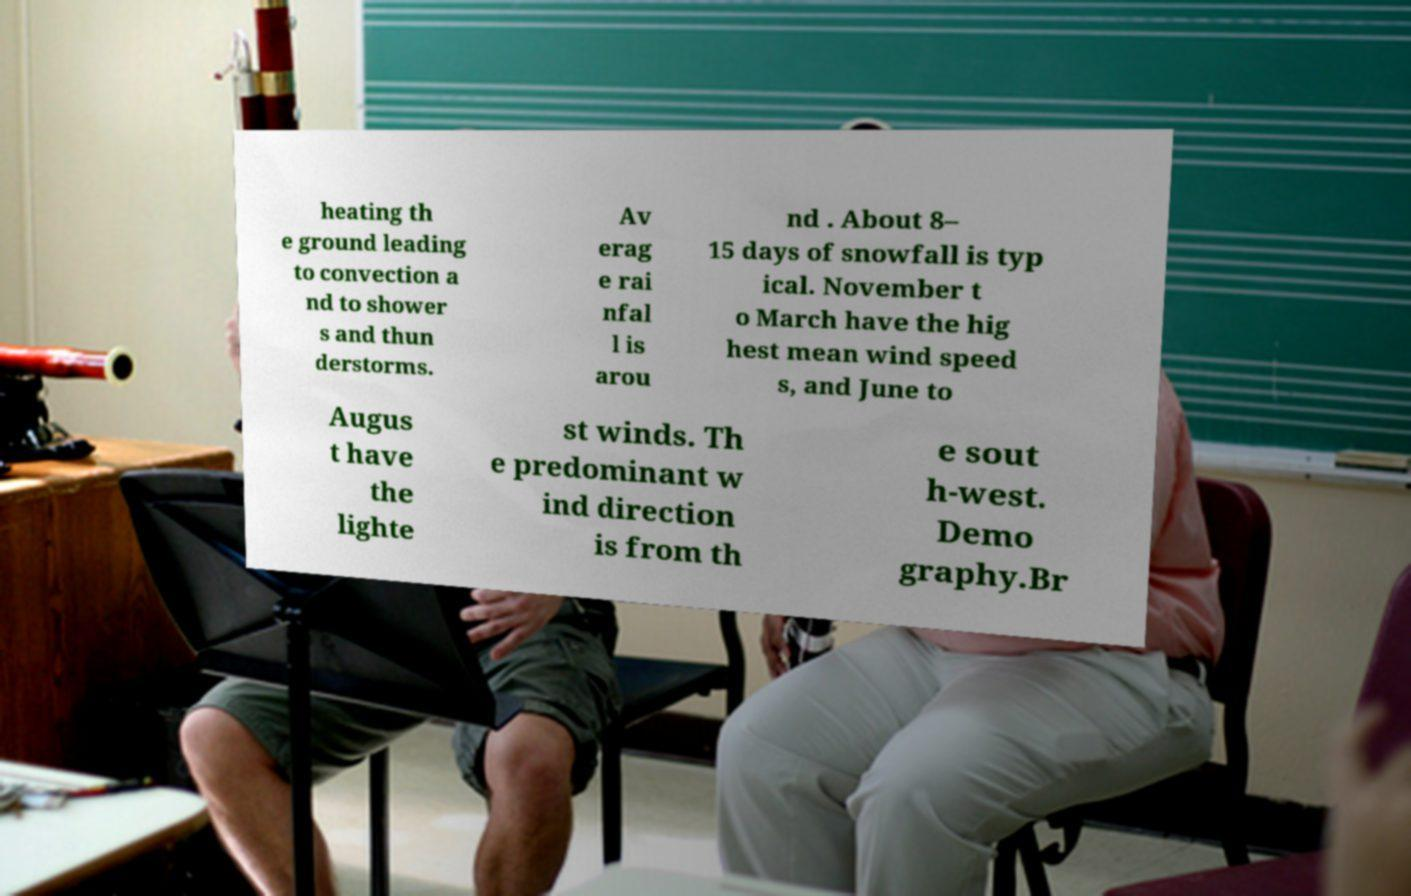There's text embedded in this image that I need extracted. Can you transcribe it verbatim? heating th e ground leading to convection a nd to shower s and thun derstorms. Av erag e rai nfal l is arou nd . About 8– 15 days of snowfall is typ ical. November t o March have the hig hest mean wind speed s, and June to Augus t have the lighte st winds. Th e predominant w ind direction is from th e sout h-west. Demo graphy.Br 